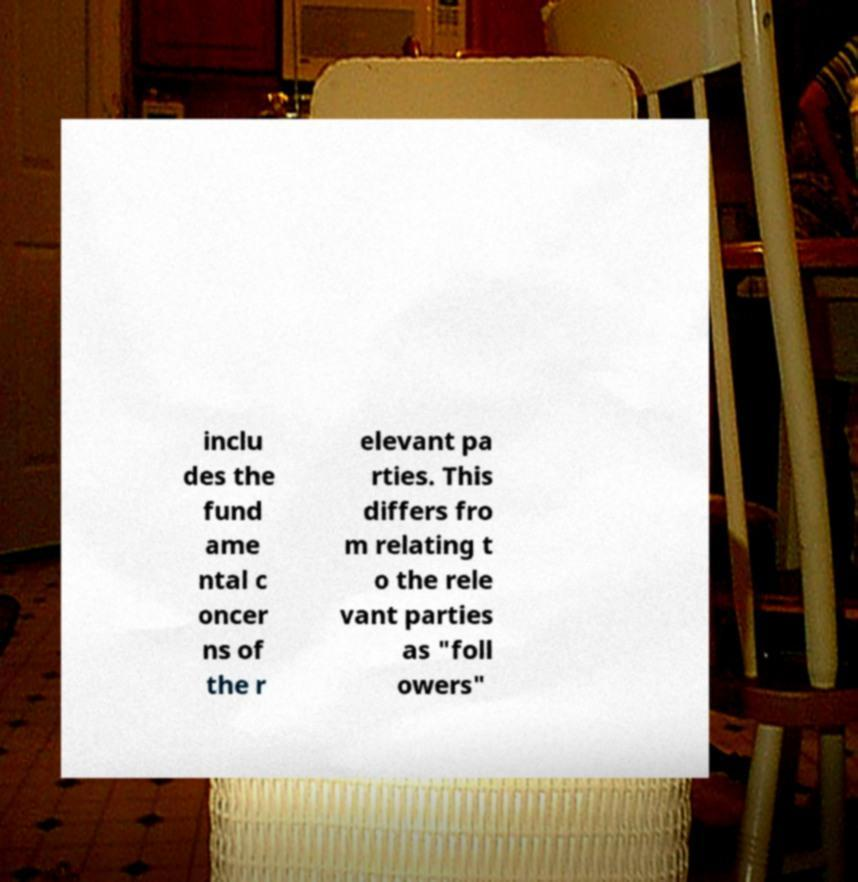For documentation purposes, I need the text within this image transcribed. Could you provide that? inclu des the fund ame ntal c oncer ns of the r elevant pa rties. This differs fro m relating t o the rele vant parties as "foll owers" 